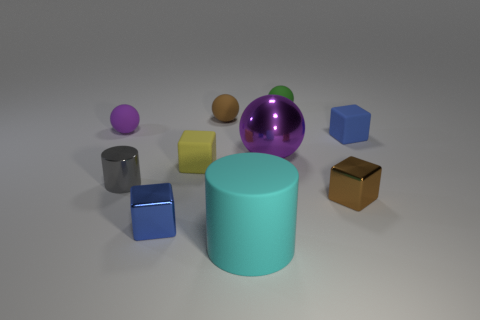Are there more gray things that are to the right of the big ball than small green spheres on the left side of the small gray thing?
Provide a succinct answer. No. How many other objects are there of the same size as the yellow rubber cube?
Provide a short and direct response. 7. What is the size of the other object that is the same color as the large metallic thing?
Your answer should be very brief. Small. What is the blue block that is left of the small brown thing left of the large cyan object made of?
Keep it short and to the point. Metal. Are there any tiny gray metal cylinders on the right side of the brown matte sphere?
Your response must be concise. No. Are there more large spheres that are on the left side of the matte cylinder than purple rubber things?
Provide a succinct answer. No. Are there any cubes that have the same color as the metallic cylinder?
Ensure brevity in your answer.  No. There is a metal cylinder that is the same size as the brown cube; what is its color?
Ensure brevity in your answer.  Gray. There is a tiny yellow thing in front of the purple metal object; are there any tiny matte things in front of it?
Make the answer very short. No. What material is the small blue cube that is to the left of the small yellow object?
Your response must be concise. Metal. 